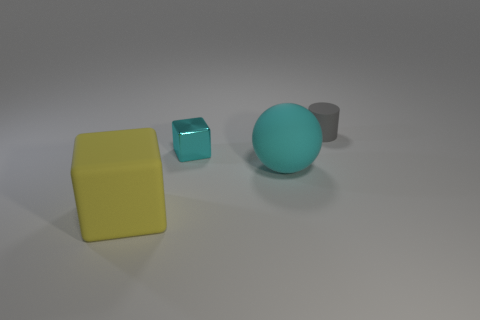Add 4 big brown metal cylinders. How many objects exist? 8 Subtract all spheres. How many objects are left? 3 Add 1 tiny rubber cylinders. How many tiny rubber cylinders exist? 2 Subtract 1 cyan blocks. How many objects are left? 3 Subtract all small matte things. Subtract all tiny gray things. How many objects are left? 2 Add 2 large yellow matte objects. How many large yellow matte objects are left? 3 